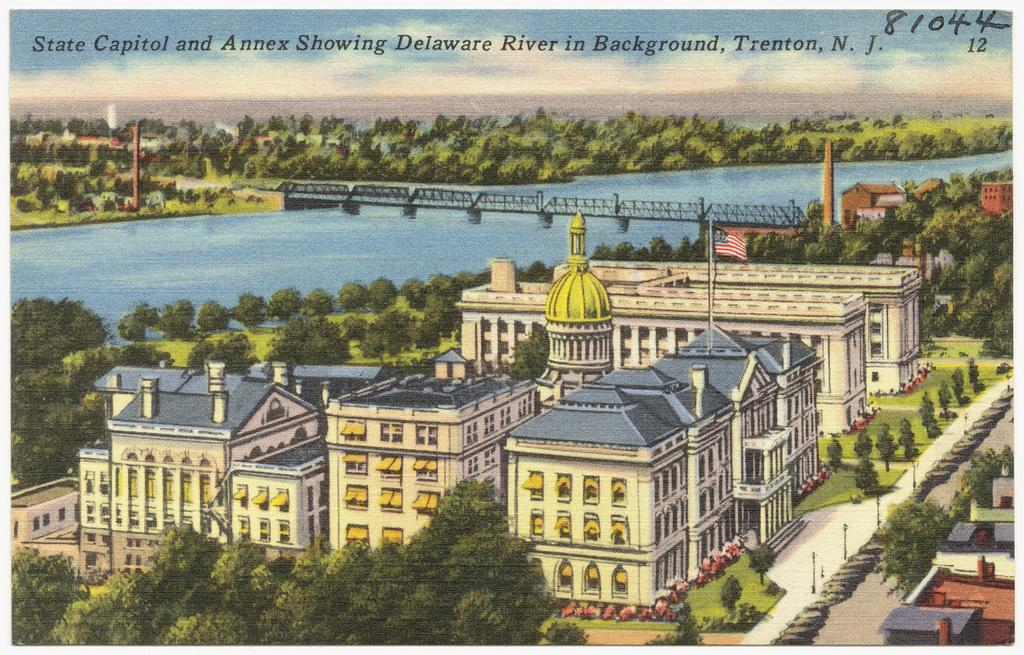<image>
Give a short and clear explanation of the subsequent image. An artist's rendition of a State Capitol building in Delaware. 